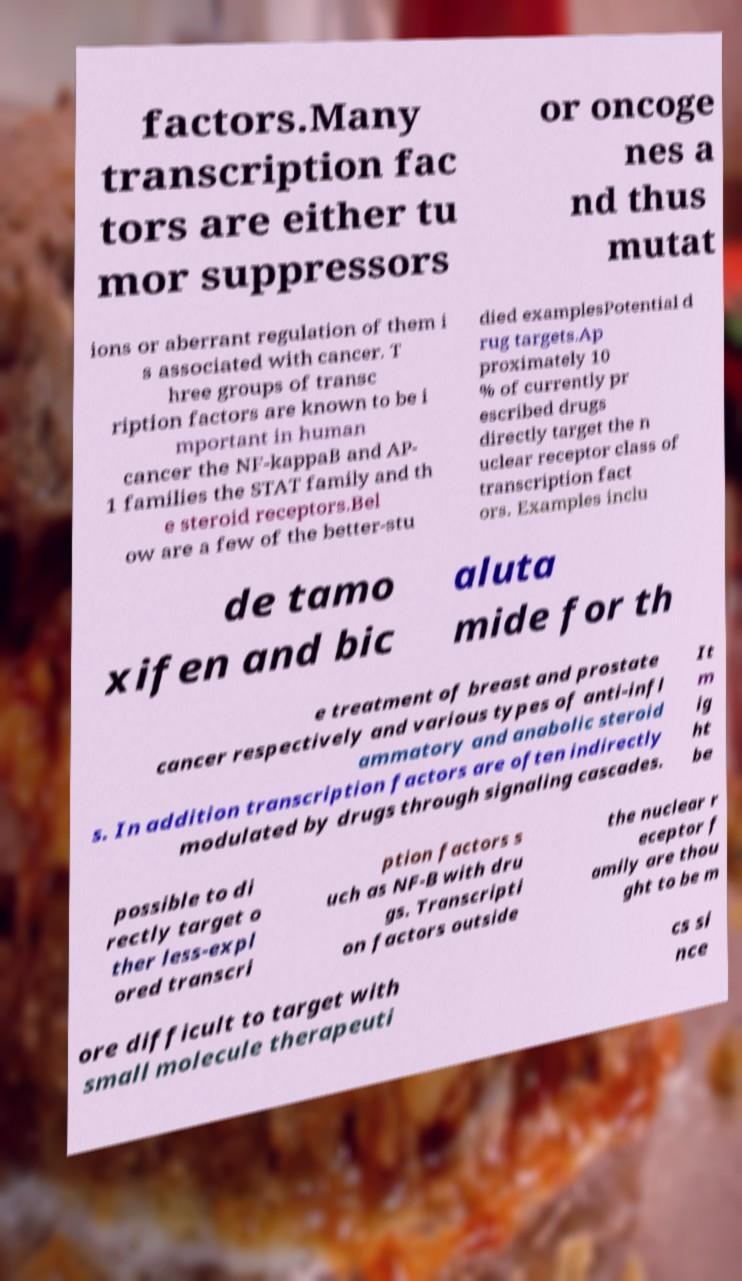There's text embedded in this image that I need extracted. Can you transcribe it verbatim? factors.Many transcription fac tors are either tu mor suppressors or oncoge nes a nd thus mutat ions or aberrant regulation of them i s associated with cancer. T hree groups of transc ription factors are known to be i mportant in human cancer the NF-kappaB and AP- 1 families the STAT family and th e steroid receptors.Bel ow are a few of the better-stu died examplesPotential d rug targets.Ap proximately 10 % of currently pr escribed drugs directly target the n uclear receptor class of transcription fact ors. Examples inclu de tamo xifen and bic aluta mide for th e treatment of breast and prostate cancer respectively and various types of anti-infl ammatory and anabolic steroid s. In addition transcription factors are often indirectly modulated by drugs through signaling cascades. It m ig ht be possible to di rectly target o ther less-expl ored transcri ption factors s uch as NF-B with dru gs. Transcripti on factors outside the nuclear r eceptor f amily are thou ght to be m ore difficult to target with small molecule therapeuti cs si nce 